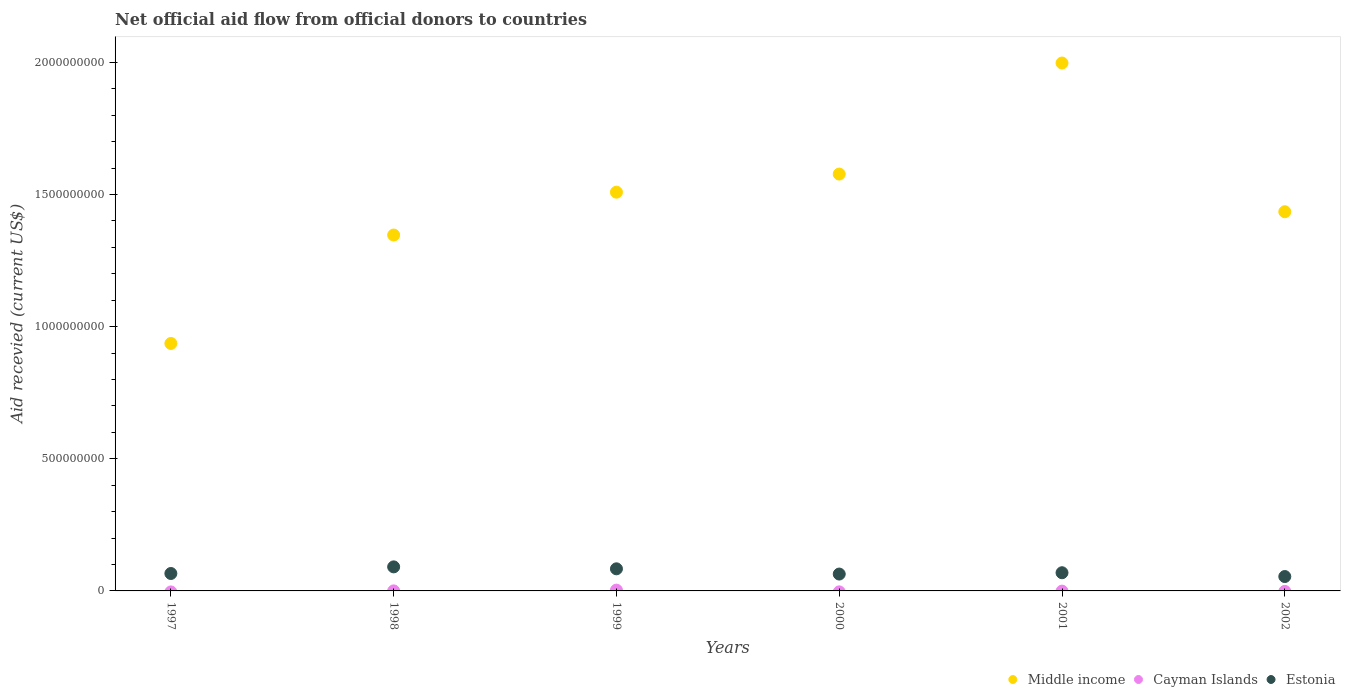How many different coloured dotlines are there?
Make the answer very short. 3. What is the total aid received in Middle income in 1998?
Your response must be concise. 1.35e+09. Across all years, what is the maximum total aid received in Middle income?
Your response must be concise. 2.00e+09. Across all years, what is the minimum total aid received in Middle income?
Your answer should be very brief. 9.36e+08. What is the total total aid received in Cayman Islands in the graph?
Give a very brief answer. 3.17e+06. What is the difference between the total aid received in Middle income in 1997 and that in 2001?
Provide a short and direct response. -1.06e+09. What is the difference between the total aid received in Estonia in 2002 and the total aid received in Cayman Islands in 2000?
Provide a succinct answer. 5.44e+07. What is the average total aid received in Estonia per year?
Ensure brevity in your answer.  7.13e+07. In the year 1998, what is the difference between the total aid received in Estonia and total aid received in Middle income?
Make the answer very short. -1.26e+09. What is the ratio of the total aid received in Estonia in 1998 to that in 2000?
Your answer should be very brief. 1.43. Is the total aid received in Middle income in 2000 less than that in 2001?
Offer a terse response. Yes. Is the difference between the total aid received in Estonia in 1999 and 2001 greater than the difference between the total aid received in Middle income in 1999 and 2001?
Offer a terse response. Yes. What is the difference between the highest and the second highest total aid received in Middle income?
Your answer should be very brief. 4.20e+08. What is the difference between the highest and the lowest total aid received in Cayman Islands?
Keep it short and to the point. 3.01e+06. In how many years, is the total aid received in Middle income greater than the average total aid received in Middle income taken over all years?
Make the answer very short. 3. Is it the case that in every year, the sum of the total aid received in Cayman Islands and total aid received in Estonia  is greater than the total aid received in Middle income?
Your answer should be compact. No. How many dotlines are there?
Make the answer very short. 3. How many years are there in the graph?
Your answer should be compact. 6. Does the graph contain any zero values?
Give a very brief answer. Yes. Does the graph contain grids?
Offer a terse response. No. What is the title of the graph?
Keep it short and to the point. Net official aid flow from official donors to countries. Does "Small states" appear as one of the legend labels in the graph?
Provide a succinct answer. No. What is the label or title of the Y-axis?
Make the answer very short. Aid recevied (current US$). What is the Aid recevied (current US$) of Middle income in 1997?
Your answer should be compact. 9.36e+08. What is the Aid recevied (current US$) of Cayman Islands in 1997?
Offer a terse response. 0. What is the Aid recevied (current US$) of Estonia in 1997?
Provide a succinct answer. 6.59e+07. What is the Aid recevied (current US$) of Middle income in 1998?
Ensure brevity in your answer.  1.35e+09. What is the Aid recevied (current US$) in Estonia in 1998?
Provide a succinct answer. 9.10e+07. What is the Aid recevied (current US$) in Middle income in 1999?
Keep it short and to the point. 1.51e+09. What is the Aid recevied (current US$) of Cayman Islands in 1999?
Provide a succinct answer. 3.01e+06. What is the Aid recevied (current US$) of Estonia in 1999?
Your answer should be compact. 8.36e+07. What is the Aid recevied (current US$) of Middle income in 2000?
Your answer should be very brief. 1.58e+09. What is the Aid recevied (current US$) in Cayman Islands in 2000?
Offer a terse response. 0. What is the Aid recevied (current US$) in Estonia in 2000?
Ensure brevity in your answer.  6.38e+07. What is the Aid recevied (current US$) of Middle income in 2001?
Provide a short and direct response. 2.00e+09. What is the Aid recevied (current US$) of Cayman Islands in 2001?
Offer a very short reply. 0. What is the Aid recevied (current US$) in Estonia in 2001?
Provide a succinct answer. 6.88e+07. What is the Aid recevied (current US$) of Middle income in 2002?
Give a very brief answer. 1.43e+09. What is the Aid recevied (current US$) of Estonia in 2002?
Your answer should be very brief. 5.44e+07. Across all years, what is the maximum Aid recevied (current US$) in Middle income?
Your response must be concise. 2.00e+09. Across all years, what is the maximum Aid recevied (current US$) of Cayman Islands?
Your answer should be compact. 3.01e+06. Across all years, what is the maximum Aid recevied (current US$) in Estonia?
Your answer should be compact. 9.10e+07. Across all years, what is the minimum Aid recevied (current US$) in Middle income?
Give a very brief answer. 9.36e+08. Across all years, what is the minimum Aid recevied (current US$) in Cayman Islands?
Give a very brief answer. 0. Across all years, what is the minimum Aid recevied (current US$) in Estonia?
Provide a short and direct response. 5.44e+07. What is the total Aid recevied (current US$) in Middle income in the graph?
Offer a terse response. 8.80e+09. What is the total Aid recevied (current US$) in Cayman Islands in the graph?
Your response must be concise. 3.17e+06. What is the total Aid recevied (current US$) in Estonia in the graph?
Make the answer very short. 4.28e+08. What is the difference between the Aid recevied (current US$) of Middle income in 1997 and that in 1998?
Your answer should be very brief. -4.10e+08. What is the difference between the Aid recevied (current US$) of Estonia in 1997 and that in 1998?
Offer a very short reply. -2.51e+07. What is the difference between the Aid recevied (current US$) of Middle income in 1997 and that in 1999?
Offer a very short reply. -5.72e+08. What is the difference between the Aid recevied (current US$) of Estonia in 1997 and that in 1999?
Make the answer very short. -1.77e+07. What is the difference between the Aid recevied (current US$) of Middle income in 1997 and that in 2000?
Provide a short and direct response. -6.41e+08. What is the difference between the Aid recevied (current US$) of Estonia in 1997 and that in 2000?
Give a very brief answer. 2.08e+06. What is the difference between the Aid recevied (current US$) of Middle income in 1997 and that in 2001?
Your answer should be very brief. -1.06e+09. What is the difference between the Aid recevied (current US$) of Estonia in 1997 and that in 2001?
Give a very brief answer. -2.87e+06. What is the difference between the Aid recevied (current US$) of Middle income in 1997 and that in 2002?
Your answer should be very brief. -4.98e+08. What is the difference between the Aid recevied (current US$) of Estonia in 1997 and that in 2002?
Your response must be concise. 1.15e+07. What is the difference between the Aid recevied (current US$) of Middle income in 1998 and that in 1999?
Your answer should be very brief. -1.62e+08. What is the difference between the Aid recevied (current US$) of Cayman Islands in 1998 and that in 1999?
Give a very brief answer. -2.85e+06. What is the difference between the Aid recevied (current US$) of Estonia in 1998 and that in 1999?
Provide a succinct answer. 7.37e+06. What is the difference between the Aid recevied (current US$) in Middle income in 1998 and that in 2000?
Your answer should be very brief. -2.31e+08. What is the difference between the Aid recevied (current US$) of Estonia in 1998 and that in 2000?
Provide a short and direct response. 2.72e+07. What is the difference between the Aid recevied (current US$) of Middle income in 1998 and that in 2001?
Provide a short and direct response. -6.51e+08. What is the difference between the Aid recevied (current US$) in Estonia in 1998 and that in 2001?
Give a very brief answer. 2.22e+07. What is the difference between the Aid recevied (current US$) in Middle income in 1998 and that in 2002?
Keep it short and to the point. -8.82e+07. What is the difference between the Aid recevied (current US$) in Estonia in 1998 and that in 2002?
Your answer should be compact. 3.66e+07. What is the difference between the Aid recevied (current US$) in Middle income in 1999 and that in 2000?
Your response must be concise. -6.85e+07. What is the difference between the Aid recevied (current US$) of Estonia in 1999 and that in 2000?
Your answer should be compact. 1.98e+07. What is the difference between the Aid recevied (current US$) of Middle income in 1999 and that in 2001?
Provide a succinct answer. -4.89e+08. What is the difference between the Aid recevied (current US$) in Estonia in 1999 and that in 2001?
Offer a terse response. 1.48e+07. What is the difference between the Aid recevied (current US$) in Middle income in 1999 and that in 2002?
Offer a very short reply. 7.39e+07. What is the difference between the Aid recevied (current US$) of Estonia in 1999 and that in 2002?
Your answer should be very brief. 2.92e+07. What is the difference between the Aid recevied (current US$) of Middle income in 2000 and that in 2001?
Offer a very short reply. -4.20e+08. What is the difference between the Aid recevied (current US$) of Estonia in 2000 and that in 2001?
Offer a very short reply. -4.95e+06. What is the difference between the Aid recevied (current US$) of Middle income in 2000 and that in 2002?
Offer a terse response. 1.42e+08. What is the difference between the Aid recevied (current US$) of Estonia in 2000 and that in 2002?
Give a very brief answer. 9.42e+06. What is the difference between the Aid recevied (current US$) in Middle income in 2001 and that in 2002?
Provide a succinct answer. 5.63e+08. What is the difference between the Aid recevied (current US$) of Estonia in 2001 and that in 2002?
Keep it short and to the point. 1.44e+07. What is the difference between the Aid recevied (current US$) in Middle income in 1997 and the Aid recevied (current US$) in Cayman Islands in 1998?
Your answer should be very brief. 9.36e+08. What is the difference between the Aid recevied (current US$) of Middle income in 1997 and the Aid recevied (current US$) of Estonia in 1998?
Offer a very short reply. 8.45e+08. What is the difference between the Aid recevied (current US$) of Middle income in 1997 and the Aid recevied (current US$) of Cayman Islands in 1999?
Give a very brief answer. 9.33e+08. What is the difference between the Aid recevied (current US$) of Middle income in 1997 and the Aid recevied (current US$) of Estonia in 1999?
Provide a succinct answer. 8.53e+08. What is the difference between the Aid recevied (current US$) in Middle income in 1997 and the Aid recevied (current US$) in Estonia in 2000?
Provide a short and direct response. 8.72e+08. What is the difference between the Aid recevied (current US$) of Middle income in 1997 and the Aid recevied (current US$) of Estonia in 2001?
Offer a terse response. 8.67e+08. What is the difference between the Aid recevied (current US$) of Middle income in 1997 and the Aid recevied (current US$) of Estonia in 2002?
Your answer should be very brief. 8.82e+08. What is the difference between the Aid recevied (current US$) of Middle income in 1998 and the Aid recevied (current US$) of Cayman Islands in 1999?
Make the answer very short. 1.34e+09. What is the difference between the Aid recevied (current US$) in Middle income in 1998 and the Aid recevied (current US$) in Estonia in 1999?
Offer a terse response. 1.26e+09. What is the difference between the Aid recevied (current US$) in Cayman Islands in 1998 and the Aid recevied (current US$) in Estonia in 1999?
Your answer should be compact. -8.35e+07. What is the difference between the Aid recevied (current US$) of Middle income in 1998 and the Aid recevied (current US$) of Estonia in 2000?
Ensure brevity in your answer.  1.28e+09. What is the difference between the Aid recevied (current US$) in Cayman Islands in 1998 and the Aid recevied (current US$) in Estonia in 2000?
Your answer should be very brief. -6.37e+07. What is the difference between the Aid recevied (current US$) in Middle income in 1998 and the Aid recevied (current US$) in Estonia in 2001?
Give a very brief answer. 1.28e+09. What is the difference between the Aid recevied (current US$) in Cayman Islands in 1998 and the Aid recevied (current US$) in Estonia in 2001?
Your answer should be compact. -6.86e+07. What is the difference between the Aid recevied (current US$) in Middle income in 1998 and the Aid recevied (current US$) in Estonia in 2002?
Your response must be concise. 1.29e+09. What is the difference between the Aid recevied (current US$) of Cayman Islands in 1998 and the Aid recevied (current US$) of Estonia in 2002?
Make the answer very short. -5.42e+07. What is the difference between the Aid recevied (current US$) in Middle income in 1999 and the Aid recevied (current US$) in Estonia in 2000?
Offer a terse response. 1.44e+09. What is the difference between the Aid recevied (current US$) of Cayman Islands in 1999 and the Aid recevied (current US$) of Estonia in 2000?
Your response must be concise. -6.08e+07. What is the difference between the Aid recevied (current US$) of Middle income in 1999 and the Aid recevied (current US$) of Estonia in 2001?
Provide a short and direct response. 1.44e+09. What is the difference between the Aid recevied (current US$) in Cayman Islands in 1999 and the Aid recevied (current US$) in Estonia in 2001?
Ensure brevity in your answer.  -6.58e+07. What is the difference between the Aid recevied (current US$) of Middle income in 1999 and the Aid recevied (current US$) of Estonia in 2002?
Give a very brief answer. 1.45e+09. What is the difference between the Aid recevied (current US$) in Cayman Islands in 1999 and the Aid recevied (current US$) in Estonia in 2002?
Offer a terse response. -5.14e+07. What is the difference between the Aid recevied (current US$) in Middle income in 2000 and the Aid recevied (current US$) in Estonia in 2001?
Your response must be concise. 1.51e+09. What is the difference between the Aid recevied (current US$) in Middle income in 2000 and the Aid recevied (current US$) in Estonia in 2002?
Your response must be concise. 1.52e+09. What is the difference between the Aid recevied (current US$) in Middle income in 2001 and the Aid recevied (current US$) in Estonia in 2002?
Offer a terse response. 1.94e+09. What is the average Aid recevied (current US$) of Middle income per year?
Provide a short and direct response. 1.47e+09. What is the average Aid recevied (current US$) of Cayman Islands per year?
Offer a very short reply. 5.28e+05. What is the average Aid recevied (current US$) in Estonia per year?
Offer a very short reply. 7.13e+07. In the year 1997, what is the difference between the Aid recevied (current US$) in Middle income and Aid recevied (current US$) in Estonia?
Provide a succinct answer. 8.70e+08. In the year 1998, what is the difference between the Aid recevied (current US$) of Middle income and Aid recevied (current US$) of Cayman Islands?
Provide a short and direct response. 1.35e+09. In the year 1998, what is the difference between the Aid recevied (current US$) of Middle income and Aid recevied (current US$) of Estonia?
Give a very brief answer. 1.26e+09. In the year 1998, what is the difference between the Aid recevied (current US$) in Cayman Islands and Aid recevied (current US$) in Estonia?
Ensure brevity in your answer.  -9.08e+07. In the year 1999, what is the difference between the Aid recevied (current US$) of Middle income and Aid recevied (current US$) of Cayman Islands?
Provide a short and direct response. 1.51e+09. In the year 1999, what is the difference between the Aid recevied (current US$) of Middle income and Aid recevied (current US$) of Estonia?
Offer a terse response. 1.42e+09. In the year 1999, what is the difference between the Aid recevied (current US$) in Cayman Islands and Aid recevied (current US$) in Estonia?
Provide a succinct answer. -8.06e+07. In the year 2000, what is the difference between the Aid recevied (current US$) in Middle income and Aid recevied (current US$) in Estonia?
Offer a very short reply. 1.51e+09. In the year 2001, what is the difference between the Aid recevied (current US$) of Middle income and Aid recevied (current US$) of Estonia?
Offer a very short reply. 1.93e+09. In the year 2002, what is the difference between the Aid recevied (current US$) in Middle income and Aid recevied (current US$) in Estonia?
Your response must be concise. 1.38e+09. What is the ratio of the Aid recevied (current US$) in Middle income in 1997 to that in 1998?
Provide a short and direct response. 0.7. What is the ratio of the Aid recevied (current US$) in Estonia in 1997 to that in 1998?
Your response must be concise. 0.72. What is the ratio of the Aid recevied (current US$) in Middle income in 1997 to that in 1999?
Your answer should be very brief. 0.62. What is the ratio of the Aid recevied (current US$) of Estonia in 1997 to that in 1999?
Give a very brief answer. 0.79. What is the ratio of the Aid recevied (current US$) of Middle income in 1997 to that in 2000?
Offer a terse response. 0.59. What is the ratio of the Aid recevied (current US$) in Estonia in 1997 to that in 2000?
Your answer should be very brief. 1.03. What is the ratio of the Aid recevied (current US$) in Middle income in 1997 to that in 2001?
Give a very brief answer. 0.47. What is the ratio of the Aid recevied (current US$) in Middle income in 1997 to that in 2002?
Your answer should be very brief. 0.65. What is the ratio of the Aid recevied (current US$) of Estonia in 1997 to that in 2002?
Your response must be concise. 1.21. What is the ratio of the Aid recevied (current US$) in Middle income in 1998 to that in 1999?
Make the answer very short. 0.89. What is the ratio of the Aid recevied (current US$) of Cayman Islands in 1998 to that in 1999?
Make the answer very short. 0.05. What is the ratio of the Aid recevied (current US$) of Estonia in 1998 to that in 1999?
Provide a succinct answer. 1.09. What is the ratio of the Aid recevied (current US$) in Middle income in 1998 to that in 2000?
Keep it short and to the point. 0.85. What is the ratio of the Aid recevied (current US$) of Estonia in 1998 to that in 2000?
Your response must be concise. 1.43. What is the ratio of the Aid recevied (current US$) of Middle income in 1998 to that in 2001?
Provide a short and direct response. 0.67. What is the ratio of the Aid recevied (current US$) of Estonia in 1998 to that in 2001?
Your answer should be very brief. 1.32. What is the ratio of the Aid recevied (current US$) of Middle income in 1998 to that in 2002?
Keep it short and to the point. 0.94. What is the ratio of the Aid recevied (current US$) of Estonia in 1998 to that in 2002?
Offer a very short reply. 1.67. What is the ratio of the Aid recevied (current US$) in Middle income in 1999 to that in 2000?
Offer a terse response. 0.96. What is the ratio of the Aid recevied (current US$) of Estonia in 1999 to that in 2000?
Keep it short and to the point. 1.31. What is the ratio of the Aid recevied (current US$) of Middle income in 1999 to that in 2001?
Your answer should be compact. 0.76. What is the ratio of the Aid recevied (current US$) in Estonia in 1999 to that in 2001?
Your answer should be very brief. 1.22. What is the ratio of the Aid recevied (current US$) in Middle income in 1999 to that in 2002?
Your answer should be very brief. 1.05. What is the ratio of the Aid recevied (current US$) in Estonia in 1999 to that in 2002?
Give a very brief answer. 1.54. What is the ratio of the Aid recevied (current US$) in Middle income in 2000 to that in 2001?
Your answer should be compact. 0.79. What is the ratio of the Aid recevied (current US$) of Estonia in 2000 to that in 2001?
Provide a short and direct response. 0.93. What is the ratio of the Aid recevied (current US$) in Middle income in 2000 to that in 2002?
Your answer should be very brief. 1.1. What is the ratio of the Aid recevied (current US$) in Estonia in 2000 to that in 2002?
Keep it short and to the point. 1.17. What is the ratio of the Aid recevied (current US$) of Middle income in 2001 to that in 2002?
Provide a succinct answer. 1.39. What is the ratio of the Aid recevied (current US$) of Estonia in 2001 to that in 2002?
Offer a terse response. 1.26. What is the difference between the highest and the second highest Aid recevied (current US$) of Middle income?
Ensure brevity in your answer.  4.20e+08. What is the difference between the highest and the second highest Aid recevied (current US$) in Estonia?
Make the answer very short. 7.37e+06. What is the difference between the highest and the lowest Aid recevied (current US$) in Middle income?
Your response must be concise. 1.06e+09. What is the difference between the highest and the lowest Aid recevied (current US$) in Cayman Islands?
Offer a terse response. 3.01e+06. What is the difference between the highest and the lowest Aid recevied (current US$) in Estonia?
Ensure brevity in your answer.  3.66e+07. 